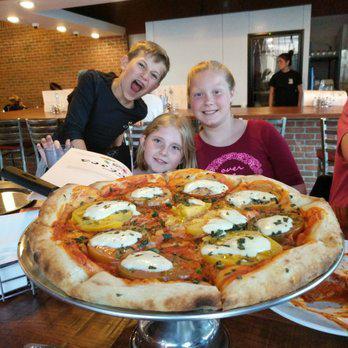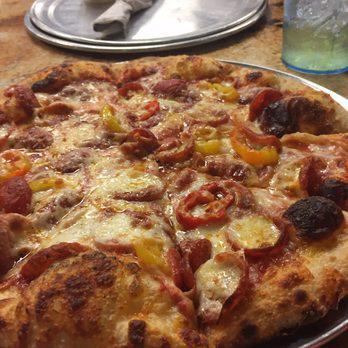The first image is the image on the left, the second image is the image on the right. Given the left and right images, does the statement "In at least one image there is a salmon and carvery pizza with at least six slices." hold true? Answer yes or no. No. The first image is the image on the left, the second image is the image on the right. Given the left and right images, does the statement "The right image features one round pizza cut into at least six wedge-shaped slices and garnished with black caviar." hold true? Answer yes or no. No. 